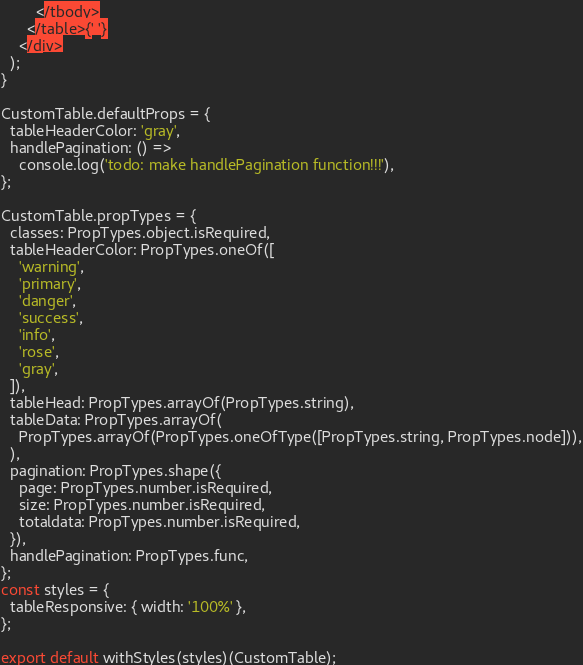<code> <loc_0><loc_0><loc_500><loc_500><_JavaScript_>        </tbody>
      </table>{' '}
    </div>
  );
}

CustomTable.defaultProps = {
  tableHeaderColor: 'gray',
  handlePagination: () =>
    console.log('todo: make handlePagination function!!!'),
};

CustomTable.propTypes = {
  classes: PropTypes.object.isRequired,
  tableHeaderColor: PropTypes.oneOf([
    'warning',
    'primary',
    'danger',
    'success',
    'info',
    'rose',
    'gray',
  ]),
  tableHead: PropTypes.arrayOf(PropTypes.string),
  tableData: PropTypes.arrayOf(
    PropTypes.arrayOf(PropTypes.oneOfType([PropTypes.string, PropTypes.node])),
  ),
  pagination: PropTypes.shape({
    page: PropTypes.number.isRequired,
    size: PropTypes.number.isRequired,
    totaldata: PropTypes.number.isRequired,
  }),
  handlePagination: PropTypes.func,
};
const styles = {
  tableResponsive: { width: '100%' },
};

export default withStyles(styles)(CustomTable);
</code> 